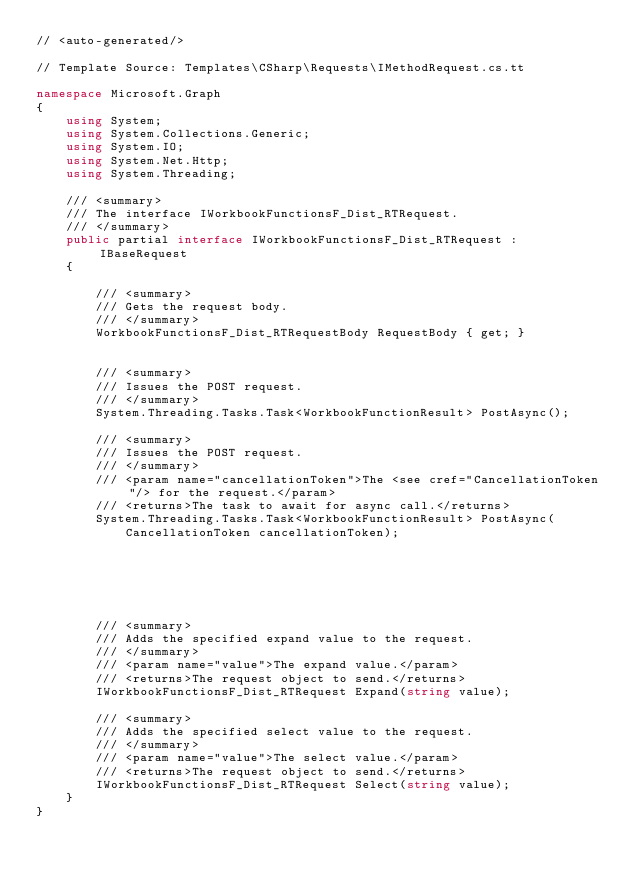<code> <loc_0><loc_0><loc_500><loc_500><_C#_>// <auto-generated/>

// Template Source: Templates\CSharp\Requests\IMethodRequest.cs.tt

namespace Microsoft.Graph
{
    using System;
    using System.Collections.Generic;
    using System.IO;
    using System.Net.Http;
    using System.Threading;

    /// <summary>
    /// The interface IWorkbookFunctionsF_Dist_RTRequest.
    /// </summary>
    public partial interface IWorkbookFunctionsF_Dist_RTRequest : IBaseRequest
    {

        /// <summary>
        /// Gets the request body.
        /// </summary>
        WorkbookFunctionsF_Dist_RTRequestBody RequestBody { get; }


        /// <summary>
        /// Issues the POST request.
        /// </summary>
        System.Threading.Tasks.Task<WorkbookFunctionResult> PostAsync();

        /// <summary>
        /// Issues the POST request.
        /// </summary>
        /// <param name="cancellationToken">The <see cref="CancellationToken"/> for the request.</param>
        /// <returns>The task to await for async call.</returns>
        System.Threading.Tasks.Task<WorkbookFunctionResult> PostAsync(
            CancellationToken cancellationToken);
        





        /// <summary>
        /// Adds the specified expand value to the request.
        /// </summary>
        /// <param name="value">The expand value.</param>
        /// <returns>The request object to send.</returns>
        IWorkbookFunctionsF_Dist_RTRequest Expand(string value);

        /// <summary>
        /// Adds the specified select value to the request.
        /// </summary>
        /// <param name="value">The select value.</param>
        /// <returns>The request object to send.</returns>
        IWorkbookFunctionsF_Dist_RTRequest Select(string value);
    }
}
</code> 